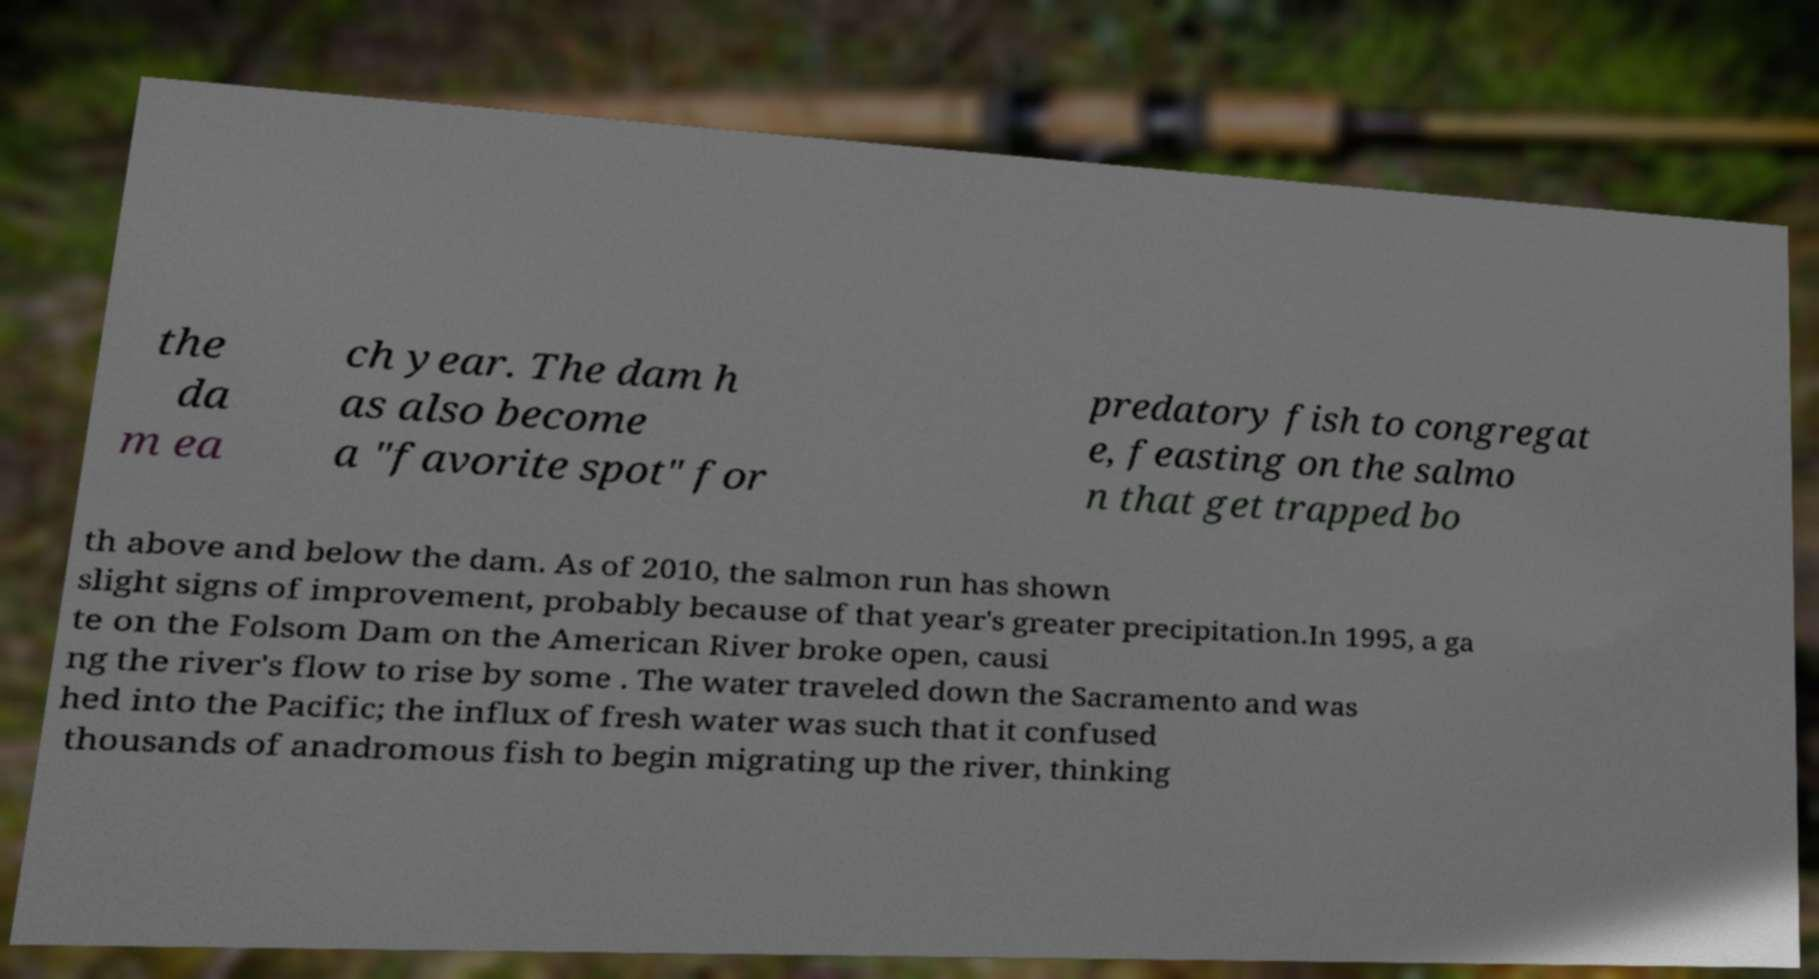Please read and relay the text visible in this image. What does it say? the da m ea ch year. The dam h as also become a "favorite spot" for predatory fish to congregat e, feasting on the salmo n that get trapped bo th above and below the dam. As of 2010, the salmon run has shown slight signs of improvement, probably because of that year's greater precipitation.In 1995, a ga te on the Folsom Dam on the American River broke open, causi ng the river's flow to rise by some . The water traveled down the Sacramento and was hed into the Pacific; the influx of fresh water was such that it confused thousands of anadromous fish to begin migrating up the river, thinking 